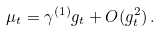<formula> <loc_0><loc_0><loc_500><loc_500>\mu _ { t } = \gamma ^ { ( 1 ) } g _ { t } + O ( g _ { t } ^ { 2 } ) \, .</formula> 